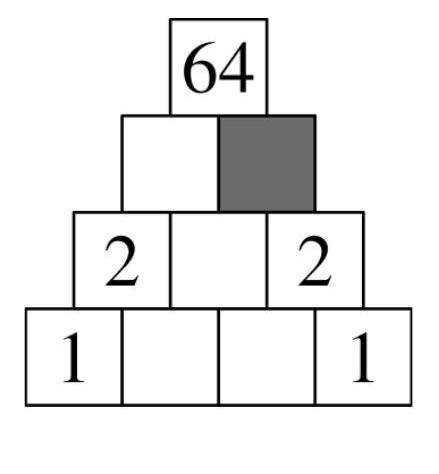Leo writes numbers in the multiplication pyramid. Explanation of the multiplication pyramid: By multiplying the numbers which are next to each other, the number directly above (in the middle) is calculated. Which number must Leo write in the grey field? The number to be written in the grey field should be 8. This is determined by multiplying the two numbers just below the grey field, which are 2 and 4. Multiplying 2 and 4 gives us 8, which satisfies the rule of the multiplication pyramid where the product of the two lower numbers equals the upper number. 